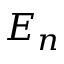<formula> <loc_0><loc_0><loc_500><loc_500>E _ { n }</formula> 